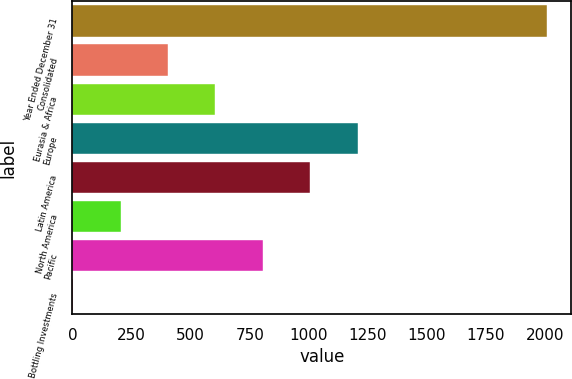Convert chart to OTSL. <chart><loc_0><loc_0><loc_500><loc_500><bar_chart><fcel>Year Ended December 31<fcel>Consolidated<fcel>Eurasia & Africa<fcel>Europe<fcel>Latin America<fcel>North America<fcel>Pacific<fcel>Bottling Investments<nl><fcel>2010<fcel>404.24<fcel>604.96<fcel>1207.12<fcel>1006.4<fcel>203.52<fcel>805.68<fcel>2.8<nl></chart> 